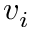<formula> <loc_0><loc_0><loc_500><loc_500>v _ { i }</formula> 